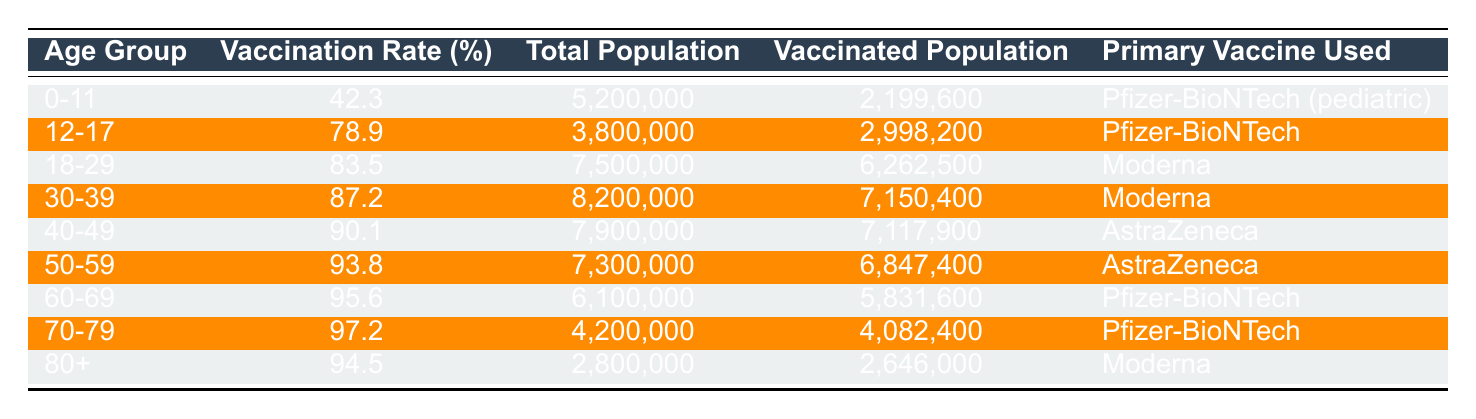What is the vaccination rate for the age group 60-69? Looking at the table, the vaccination rate for the age group 60-69 is explicitly listed next to the corresponding age group. It shows 95.6%.
Answer: 95.6% Which age group has the highest vaccination rate? By scanning the vaccination rates for all age groups, the highest rate is found for the age group 70-79, with a rate of 97.2%.
Answer: 70-79 What is the total population for the age group 30-39? The table presents the total population for each age group, and for the age group 30-39, it is listed as 8,200,000.
Answer: 8,200,000 How many people in the age group 12-17 are fully vaccinated? In the table, the number of vaccinated people in the age group 12-17 is denoted as 2,998,200.
Answer: 2,998,200 What is the average vaccination rate for the age groups 0-11, 12-17, and 18-29? First, find the vaccination rates for these age groups: 42.3%, 78.9%, and 83.5%. Next, sum these rates: 42.3 + 78.9 + 83.5 = 204.7. Then, divide by the number of age groups (3): 204.7 / 3 = 68.23%.
Answer: 68.23% Is the primary vaccine used for the age group 40-49 AstraZeneca? Referring to the table, it states that the primary vaccine used for the age group 40-49 is AstraZeneca. Thus, this statement is true.
Answer: Yes How many more people are vaccinated in the age group 70-79 compared to the age group 60-69? From the table, the vaccinated population for age group 70-79 is 4,082,400 and for 60-69 is 5,831,600. Calculating the difference: 4,082,400 - 5,831,600 gives -1,749,200, indicating that there are fewer vaccinated people in 70-79 compared to 60-69.
Answer: 1,749,200 fewer What percentage of the population aged 50-59 is vaccinated? The table shows that the vaccinated population for the age group 50-59 is 6,847,400 and the total population is 7,300,000. The vaccination percentage is calculated as (6,847,400 / 7,300,000) * 100 = 93.8%.
Answer: 93.8% Which age group has the lowest vaccination rate, and what is that rate? By comparing the vaccination rates, the lowest rate is for the age group 0-11 at 42.3%.
Answer: 0-11, 42.3% If the age group 80+ had a vaccination rate increase of 5%, what would that new rate be? The current vaccination rate for the age group 80+ is 94.5%. Adding 5% gives: 94.5% + 5% = 99.5%.
Answer: 99.5% 